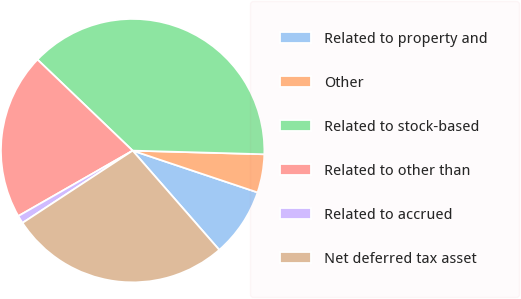Convert chart to OTSL. <chart><loc_0><loc_0><loc_500><loc_500><pie_chart><fcel>Related to property and<fcel>Other<fcel>Related to stock-based<fcel>Related to other than<fcel>Related to accrued<fcel>Net deferred tax asset<nl><fcel>8.44%<fcel>4.7%<fcel>38.29%<fcel>20.42%<fcel>0.97%<fcel>27.18%<nl></chart> 